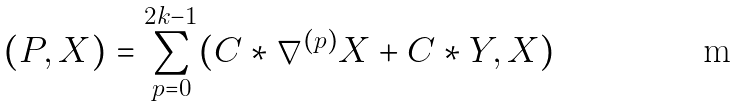Convert formula to latex. <formula><loc_0><loc_0><loc_500><loc_500>( P , X ) = \sum _ { p = 0 } ^ { 2 k - 1 } ( C \ast \nabla ^ { ( p ) } X + C \ast Y , X )</formula> 